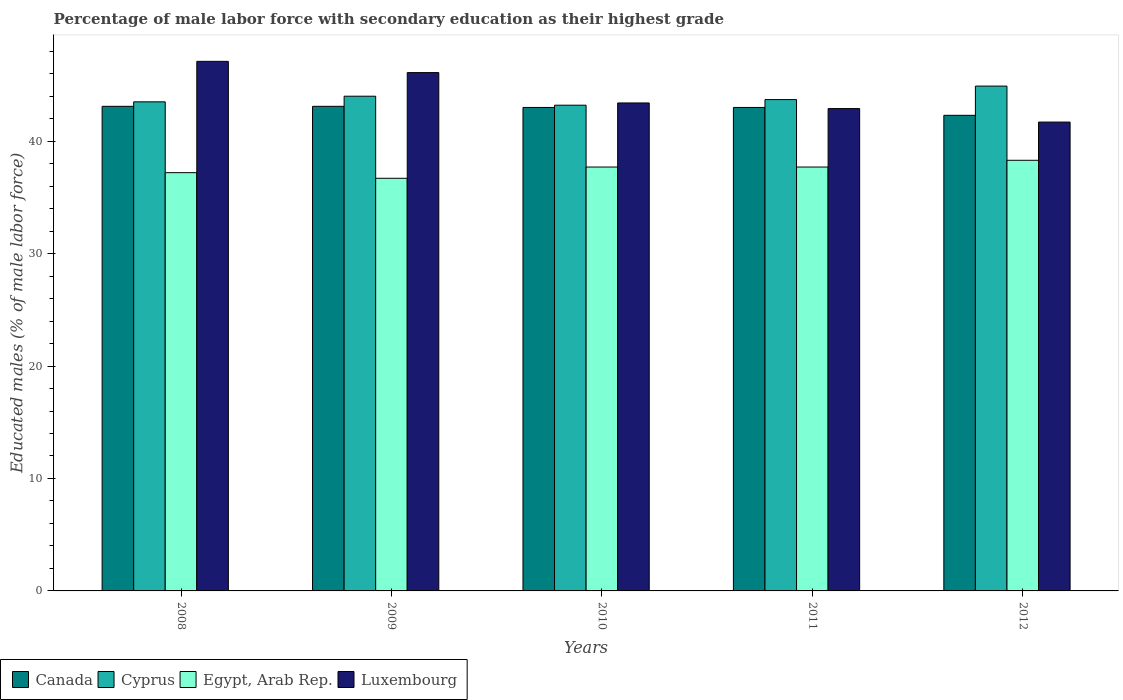How many different coloured bars are there?
Offer a terse response. 4. How many groups of bars are there?
Your answer should be very brief. 5. Are the number of bars per tick equal to the number of legend labels?
Your answer should be compact. Yes. How many bars are there on the 1st tick from the left?
Your response must be concise. 4. What is the label of the 5th group of bars from the left?
Provide a short and direct response. 2012. What is the percentage of male labor force with secondary education in Luxembourg in 2010?
Ensure brevity in your answer.  43.4. Across all years, what is the maximum percentage of male labor force with secondary education in Cyprus?
Keep it short and to the point. 44.9. Across all years, what is the minimum percentage of male labor force with secondary education in Egypt, Arab Rep.?
Offer a very short reply. 36.7. In which year was the percentage of male labor force with secondary education in Cyprus minimum?
Ensure brevity in your answer.  2010. What is the total percentage of male labor force with secondary education in Luxembourg in the graph?
Ensure brevity in your answer.  221.2. What is the difference between the percentage of male labor force with secondary education in Egypt, Arab Rep. in 2008 and the percentage of male labor force with secondary education in Canada in 2012?
Your answer should be compact. -5.1. What is the average percentage of male labor force with secondary education in Egypt, Arab Rep. per year?
Make the answer very short. 37.52. In the year 2008, what is the difference between the percentage of male labor force with secondary education in Egypt, Arab Rep. and percentage of male labor force with secondary education in Cyprus?
Your answer should be compact. -6.3. In how many years, is the percentage of male labor force with secondary education in Egypt, Arab Rep. greater than 4 %?
Offer a terse response. 5. What is the ratio of the percentage of male labor force with secondary education in Egypt, Arab Rep. in 2011 to that in 2012?
Provide a succinct answer. 0.98. Is the percentage of male labor force with secondary education in Luxembourg in 2009 less than that in 2010?
Offer a very short reply. No. Is the difference between the percentage of male labor force with secondary education in Egypt, Arab Rep. in 2008 and 2012 greater than the difference between the percentage of male labor force with secondary education in Cyprus in 2008 and 2012?
Your answer should be very brief. Yes. What is the difference between the highest and the second highest percentage of male labor force with secondary education in Egypt, Arab Rep.?
Your answer should be compact. 0.6. What is the difference between the highest and the lowest percentage of male labor force with secondary education in Cyprus?
Keep it short and to the point. 1.7. Is the sum of the percentage of male labor force with secondary education in Cyprus in 2010 and 2011 greater than the maximum percentage of male labor force with secondary education in Egypt, Arab Rep. across all years?
Make the answer very short. Yes. What does the 3rd bar from the left in 2009 represents?
Provide a succinct answer. Egypt, Arab Rep. What does the 3rd bar from the right in 2008 represents?
Make the answer very short. Cyprus. How many years are there in the graph?
Provide a succinct answer. 5. What is the difference between two consecutive major ticks on the Y-axis?
Provide a short and direct response. 10. Does the graph contain grids?
Make the answer very short. No. Where does the legend appear in the graph?
Your response must be concise. Bottom left. What is the title of the graph?
Give a very brief answer. Percentage of male labor force with secondary education as their highest grade. What is the label or title of the X-axis?
Your answer should be compact. Years. What is the label or title of the Y-axis?
Offer a very short reply. Educated males (% of male labor force). What is the Educated males (% of male labor force) in Canada in 2008?
Offer a terse response. 43.1. What is the Educated males (% of male labor force) in Cyprus in 2008?
Offer a very short reply. 43.5. What is the Educated males (% of male labor force) in Egypt, Arab Rep. in 2008?
Make the answer very short. 37.2. What is the Educated males (% of male labor force) of Luxembourg in 2008?
Give a very brief answer. 47.1. What is the Educated males (% of male labor force) of Canada in 2009?
Make the answer very short. 43.1. What is the Educated males (% of male labor force) in Egypt, Arab Rep. in 2009?
Offer a terse response. 36.7. What is the Educated males (% of male labor force) in Luxembourg in 2009?
Ensure brevity in your answer.  46.1. What is the Educated males (% of male labor force) in Canada in 2010?
Offer a terse response. 43. What is the Educated males (% of male labor force) in Cyprus in 2010?
Your response must be concise. 43.2. What is the Educated males (% of male labor force) of Egypt, Arab Rep. in 2010?
Provide a short and direct response. 37.7. What is the Educated males (% of male labor force) of Luxembourg in 2010?
Your response must be concise. 43.4. What is the Educated males (% of male labor force) in Canada in 2011?
Ensure brevity in your answer.  43. What is the Educated males (% of male labor force) in Cyprus in 2011?
Provide a succinct answer. 43.7. What is the Educated males (% of male labor force) of Egypt, Arab Rep. in 2011?
Ensure brevity in your answer.  37.7. What is the Educated males (% of male labor force) of Luxembourg in 2011?
Keep it short and to the point. 42.9. What is the Educated males (% of male labor force) in Canada in 2012?
Make the answer very short. 42.3. What is the Educated males (% of male labor force) of Cyprus in 2012?
Keep it short and to the point. 44.9. What is the Educated males (% of male labor force) of Egypt, Arab Rep. in 2012?
Provide a short and direct response. 38.3. What is the Educated males (% of male labor force) in Luxembourg in 2012?
Keep it short and to the point. 41.7. Across all years, what is the maximum Educated males (% of male labor force) in Canada?
Offer a very short reply. 43.1. Across all years, what is the maximum Educated males (% of male labor force) in Cyprus?
Offer a very short reply. 44.9. Across all years, what is the maximum Educated males (% of male labor force) of Egypt, Arab Rep.?
Provide a short and direct response. 38.3. Across all years, what is the maximum Educated males (% of male labor force) in Luxembourg?
Provide a short and direct response. 47.1. Across all years, what is the minimum Educated males (% of male labor force) in Canada?
Provide a short and direct response. 42.3. Across all years, what is the minimum Educated males (% of male labor force) in Cyprus?
Offer a terse response. 43.2. Across all years, what is the minimum Educated males (% of male labor force) of Egypt, Arab Rep.?
Your response must be concise. 36.7. Across all years, what is the minimum Educated males (% of male labor force) of Luxembourg?
Provide a short and direct response. 41.7. What is the total Educated males (% of male labor force) in Canada in the graph?
Make the answer very short. 214.5. What is the total Educated males (% of male labor force) in Cyprus in the graph?
Offer a terse response. 219.3. What is the total Educated males (% of male labor force) in Egypt, Arab Rep. in the graph?
Make the answer very short. 187.6. What is the total Educated males (% of male labor force) in Luxembourg in the graph?
Offer a terse response. 221.2. What is the difference between the Educated males (% of male labor force) in Canada in 2008 and that in 2009?
Provide a short and direct response. 0. What is the difference between the Educated males (% of male labor force) in Cyprus in 2008 and that in 2009?
Keep it short and to the point. -0.5. What is the difference between the Educated males (% of male labor force) in Egypt, Arab Rep. in 2008 and that in 2009?
Your answer should be compact. 0.5. What is the difference between the Educated males (% of male labor force) in Luxembourg in 2008 and that in 2009?
Keep it short and to the point. 1. What is the difference between the Educated males (% of male labor force) in Cyprus in 2008 and that in 2010?
Ensure brevity in your answer.  0.3. What is the difference between the Educated males (% of male labor force) of Egypt, Arab Rep. in 2008 and that in 2010?
Provide a succinct answer. -0.5. What is the difference between the Educated males (% of male labor force) of Canada in 2008 and that in 2011?
Make the answer very short. 0.1. What is the difference between the Educated males (% of male labor force) in Luxembourg in 2008 and that in 2011?
Keep it short and to the point. 4.2. What is the difference between the Educated males (% of male labor force) in Canada in 2008 and that in 2012?
Give a very brief answer. 0.8. What is the difference between the Educated males (% of male labor force) in Cyprus in 2008 and that in 2012?
Give a very brief answer. -1.4. What is the difference between the Educated males (% of male labor force) of Egypt, Arab Rep. in 2008 and that in 2012?
Provide a succinct answer. -1.1. What is the difference between the Educated males (% of male labor force) in Egypt, Arab Rep. in 2009 and that in 2010?
Your answer should be compact. -1. What is the difference between the Educated males (% of male labor force) of Canada in 2009 and that in 2011?
Keep it short and to the point. 0.1. What is the difference between the Educated males (% of male labor force) in Luxembourg in 2009 and that in 2011?
Your answer should be very brief. 3.2. What is the difference between the Educated males (% of male labor force) of Canada in 2009 and that in 2012?
Make the answer very short. 0.8. What is the difference between the Educated males (% of male labor force) in Cyprus in 2009 and that in 2012?
Your answer should be compact. -0.9. What is the difference between the Educated males (% of male labor force) of Egypt, Arab Rep. in 2009 and that in 2012?
Make the answer very short. -1.6. What is the difference between the Educated males (% of male labor force) of Cyprus in 2010 and that in 2011?
Offer a very short reply. -0.5. What is the difference between the Educated males (% of male labor force) in Egypt, Arab Rep. in 2010 and that in 2011?
Your response must be concise. 0. What is the difference between the Educated males (% of male labor force) in Luxembourg in 2010 and that in 2011?
Give a very brief answer. 0.5. What is the difference between the Educated males (% of male labor force) of Egypt, Arab Rep. in 2010 and that in 2012?
Provide a succinct answer. -0.6. What is the difference between the Educated males (% of male labor force) in Luxembourg in 2010 and that in 2012?
Your answer should be very brief. 1.7. What is the difference between the Educated males (% of male labor force) of Canada in 2011 and that in 2012?
Make the answer very short. 0.7. What is the difference between the Educated males (% of male labor force) of Cyprus in 2011 and that in 2012?
Offer a terse response. -1.2. What is the difference between the Educated males (% of male labor force) in Canada in 2008 and the Educated males (% of male labor force) in Cyprus in 2009?
Your response must be concise. -0.9. What is the difference between the Educated males (% of male labor force) of Canada in 2008 and the Educated males (% of male labor force) of Egypt, Arab Rep. in 2009?
Offer a terse response. 6.4. What is the difference between the Educated males (% of male labor force) of Canada in 2008 and the Educated males (% of male labor force) of Luxembourg in 2009?
Keep it short and to the point. -3. What is the difference between the Educated males (% of male labor force) in Cyprus in 2008 and the Educated males (% of male labor force) in Egypt, Arab Rep. in 2009?
Your response must be concise. 6.8. What is the difference between the Educated males (% of male labor force) in Egypt, Arab Rep. in 2008 and the Educated males (% of male labor force) in Luxembourg in 2009?
Your answer should be compact. -8.9. What is the difference between the Educated males (% of male labor force) of Canada in 2008 and the Educated males (% of male labor force) of Cyprus in 2010?
Ensure brevity in your answer.  -0.1. What is the difference between the Educated males (% of male labor force) in Canada in 2008 and the Educated males (% of male labor force) in Egypt, Arab Rep. in 2010?
Your response must be concise. 5.4. What is the difference between the Educated males (% of male labor force) of Canada in 2008 and the Educated males (% of male labor force) of Luxembourg in 2010?
Your answer should be very brief. -0.3. What is the difference between the Educated males (% of male labor force) in Cyprus in 2008 and the Educated males (% of male labor force) in Egypt, Arab Rep. in 2010?
Offer a terse response. 5.8. What is the difference between the Educated males (% of male labor force) of Cyprus in 2008 and the Educated males (% of male labor force) of Luxembourg in 2010?
Offer a terse response. 0.1. What is the difference between the Educated males (% of male labor force) in Canada in 2008 and the Educated males (% of male labor force) in Luxembourg in 2011?
Your response must be concise. 0.2. What is the difference between the Educated males (% of male labor force) in Cyprus in 2008 and the Educated males (% of male labor force) in Egypt, Arab Rep. in 2011?
Ensure brevity in your answer.  5.8. What is the difference between the Educated males (% of male labor force) in Cyprus in 2008 and the Educated males (% of male labor force) in Luxembourg in 2011?
Offer a very short reply. 0.6. What is the difference between the Educated males (% of male labor force) in Canada in 2008 and the Educated males (% of male labor force) in Egypt, Arab Rep. in 2012?
Keep it short and to the point. 4.8. What is the difference between the Educated males (% of male labor force) in Egypt, Arab Rep. in 2008 and the Educated males (% of male labor force) in Luxembourg in 2012?
Give a very brief answer. -4.5. What is the difference between the Educated males (% of male labor force) of Canada in 2009 and the Educated males (% of male labor force) of Egypt, Arab Rep. in 2010?
Your answer should be compact. 5.4. What is the difference between the Educated males (% of male labor force) in Canada in 2009 and the Educated males (% of male labor force) in Luxembourg in 2010?
Keep it short and to the point. -0.3. What is the difference between the Educated males (% of male labor force) in Cyprus in 2009 and the Educated males (% of male labor force) in Egypt, Arab Rep. in 2010?
Your answer should be compact. 6.3. What is the difference between the Educated males (% of male labor force) in Cyprus in 2009 and the Educated males (% of male labor force) in Luxembourg in 2010?
Offer a terse response. 0.6. What is the difference between the Educated males (% of male labor force) of Canada in 2009 and the Educated males (% of male labor force) of Cyprus in 2011?
Offer a very short reply. -0.6. What is the difference between the Educated males (% of male labor force) of Canada in 2009 and the Educated males (% of male labor force) of Egypt, Arab Rep. in 2011?
Ensure brevity in your answer.  5.4. What is the difference between the Educated males (% of male labor force) of Cyprus in 2009 and the Educated males (% of male labor force) of Luxembourg in 2011?
Provide a short and direct response. 1.1. What is the difference between the Educated males (% of male labor force) of Egypt, Arab Rep. in 2009 and the Educated males (% of male labor force) of Luxembourg in 2011?
Make the answer very short. -6.2. What is the difference between the Educated males (% of male labor force) in Canada in 2009 and the Educated males (% of male labor force) in Cyprus in 2012?
Provide a short and direct response. -1.8. What is the difference between the Educated males (% of male labor force) of Canada in 2009 and the Educated males (% of male labor force) of Egypt, Arab Rep. in 2012?
Your answer should be very brief. 4.8. What is the difference between the Educated males (% of male labor force) in Canada in 2009 and the Educated males (% of male labor force) in Luxembourg in 2012?
Make the answer very short. 1.4. What is the difference between the Educated males (% of male labor force) in Cyprus in 2009 and the Educated males (% of male labor force) in Luxembourg in 2012?
Offer a very short reply. 2.3. What is the difference between the Educated males (% of male labor force) in Egypt, Arab Rep. in 2009 and the Educated males (% of male labor force) in Luxembourg in 2012?
Give a very brief answer. -5. What is the difference between the Educated males (% of male labor force) of Cyprus in 2010 and the Educated males (% of male labor force) of Egypt, Arab Rep. in 2011?
Your response must be concise. 5.5. What is the difference between the Educated males (% of male labor force) of Cyprus in 2010 and the Educated males (% of male labor force) of Luxembourg in 2012?
Give a very brief answer. 1.5. What is the difference between the Educated males (% of male labor force) of Canada in 2011 and the Educated males (% of male labor force) of Egypt, Arab Rep. in 2012?
Offer a terse response. 4.7. What is the difference between the Educated males (% of male labor force) in Canada in 2011 and the Educated males (% of male labor force) in Luxembourg in 2012?
Your response must be concise. 1.3. What is the difference between the Educated males (% of male labor force) of Cyprus in 2011 and the Educated males (% of male labor force) of Luxembourg in 2012?
Make the answer very short. 2. What is the average Educated males (% of male labor force) of Canada per year?
Provide a succinct answer. 42.9. What is the average Educated males (% of male labor force) in Cyprus per year?
Your response must be concise. 43.86. What is the average Educated males (% of male labor force) of Egypt, Arab Rep. per year?
Your answer should be compact. 37.52. What is the average Educated males (% of male labor force) of Luxembourg per year?
Your answer should be compact. 44.24. In the year 2008, what is the difference between the Educated males (% of male labor force) of Canada and Educated males (% of male labor force) of Luxembourg?
Your answer should be very brief. -4. In the year 2009, what is the difference between the Educated males (% of male labor force) of Canada and Educated males (% of male labor force) of Cyprus?
Keep it short and to the point. -0.9. In the year 2009, what is the difference between the Educated males (% of male labor force) of Cyprus and Educated males (% of male labor force) of Egypt, Arab Rep.?
Your answer should be very brief. 7.3. In the year 2010, what is the difference between the Educated males (% of male labor force) of Canada and Educated males (% of male labor force) of Cyprus?
Your response must be concise. -0.2. In the year 2010, what is the difference between the Educated males (% of male labor force) in Cyprus and Educated males (% of male labor force) in Egypt, Arab Rep.?
Your answer should be very brief. 5.5. In the year 2010, what is the difference between the Educated males (% of male labor force) of Egypt, Arab Rep. and Educated males (% of male labor force) of Luxembourg?
Provide a succinct answer. -5.7. In the year 2011, what is the difference between the Educated males (% of male labor force) of Cyprus and Educated males (% of male labor force) of Egypt, Arab Rep.?
Make the answer very short. 6. In the year 2011, what is the difference between the Educated males (% of male labor force) in Egypt, Arab Rep. and Educated males (% of male labor force) in Luxembourg?
Provide a short and direct response. -5.2. In the year 2012, what is the difference between the Educated males (% of male labor force) of Cyprus and Educated males (% of male labor force) of Luxembourg?
Make the answer very short. 3.2. In the year 2012, what is the difference between the Educated males (% of male labor force) of Egypt, Arab Rep. and Educated males (% of male labor force) of Luxembourg?
Your response must be concise. -3.4. What is the ratio of the Educated males (% of male labor force) in Canada in 2008 to that in 2009?
Give a very brief answer. 1. What is the ratio of the Educated males (% of male labor force) of Cyprus in 2008 to that in 2009?
Your response must be concise. 0.99. What is the ratio of the Educated males (% of male labor force) of Egypt, Arab Rep. in 2008 to that in 2009?
Your answer should be very brief. 1.01. What is the ratio of the Educated males (% of male labor force) in Luxembourg in 2008 to that in 2009?
Provide a succinct answer. 1.02. What is the ratio of the Educated males (% of male labor force) of Canada in 2008 to that in 2010?
Your response must be concise. 1. What is the ratio of the Educated males (% of male labor force) of Cyprus in 2008 to that in 2010?
Keep it short and to the point. 1.01. What is the ratio of the Educated males (% of male labor force) of Egypt, Arab Rep. in 2008 to that in 2010?
Ensure brevity in your answer.  0.99. What is the ratio of the Educated males (% of male labor force) in Luxembourg in 2008 to that in 2010?
Ensure brevity in your answer.  1.09. What is the ratio of the Educated males (% of male labor force) in Canada in 2008 to that in 2011?
Make the answer very short. 1. What is the ratio of the Educated males (% of male labor force) of Cyprus in 2008 to that in 2011?
Make the answer very short. 1. What is the ratio of the Educated males (% of male labor force) in Egypt, Arab Rep. in 2008 to that in 2011?
Give a very brief answer. 0.99. What is the ratio of the Educated males (% of male labor force) in Luxembourg in 2008 to that in 2011?
Ensure brevity in your answer.  1.1. What is the ratio of the Educated males (% of male labor force) in Canada in 2008 to that in 2012?
Offer a very short reply. 1.02. What is the ratio of the Educated males (% of male labor force) in Cyprus in 2008 to that in 2012?
Ensure brevity in your answer.  0.97. What is the ratio of the Educated males (% of male labor force) in Egypt, Arab Rep. in 2008 to that in 2012?
Your answer should be compact. 0.97. What is the ratio of the Educated males (% of male labor force) of Luxembourg in 2008 to that in 2012?
Offer a very short reply. 1.13. What is the ratio of the Educated males (% of male labor force) of Canada in 2009 to that in 2010?
Provide a short and direct response. 1. What is the ratio of the Educated males (% of male labor force) of Cyprus in 2009 to that in 2010?
Keep it short and to the point. 1.02. What is the ratio of the Educated males (% of male labor force) of Egypt, Arab Rep. in 2009 to that in 2010?
Provide a short and direct response. 0.97. What is the ratio of the Educated males (% of male labor force) of Luxembourg in 2009 to that in 2010?
Provide a short and direct response. 1.06. What is the ratio of the Educated males (% of male labor force) in Canada in 2009 to that in 2011?
Your response must be concise. 1. What is the ratio of the Educated males (% of male labor force) of Egypt, Arab Rep. in 2009 to that in 2011?
Offer a terse response. 0.97. What is the ratio of the Educated males (% of male labor force) of Luxembourg in 2009 to that in 2011?
Give a very brief answer. 1.07. What is the ratio of the Educated males (% of male labor force) in Canada in 2009 to that in 2012?
Make the answer very short. 1.02. What is the ratio of the Educated males (% of male labor force) of Egypt, Arab Rep. in 2009 to that in 2012?
Make the answer very short. 0.96. What is the ratio of the Educated males (% of male labor force) in Luxembourg in 2009 to that in 2012?
Provide a short and direct response. 1.11. What is the ratio of the Educated males (% of male labor force) of Canada in 2010 to that in 2011?
Provide a succinct answer. 1. What is the ratio of the Educated males (% of male labor force) in Luxembourg in 2010 to that in 2011?
Provide a succinct answer. 1.01. What is the ratio of the Educated males (% of male labor force) of Canada in 2010 to that in 2012?
Provide a succinct answer. 1.02. What is the ratio of the Educated males (% of male labor force) in Cyprus in 2010 to that in 2012?
Provide a succinct answer. 0.96. What is the ratio of the Educated males (% of male labor force) of Egypt, Arab Rep. in 2010 to that in 2012?
Provide a succinct answer. 0.98. What is the ratio of the Educated males (% of male labor force) of Luxembourg in 2010 to that in 2012?
Offer a terse response. 1.04. What is the ratio of the Educated males (% of male labor force) in Canada in 2011 to that in 2012?
Make the answer very short. 1.02. What is the ratio of the Educated males (% of male labor force) of Cyprus in 2011 to that in 2012?
Offer a very short reply. 0.97. What is the ratio of the Educated males (% of male labor force) of Egypt, Arab Rep. in 2011 to that in 2012?
Your answer should be compact. 0.98. What is the ratio of the Educated males (% of male labor force) in Luxembourg in 2011 to that in 2012?
Offer a very short reply. 1.03. 